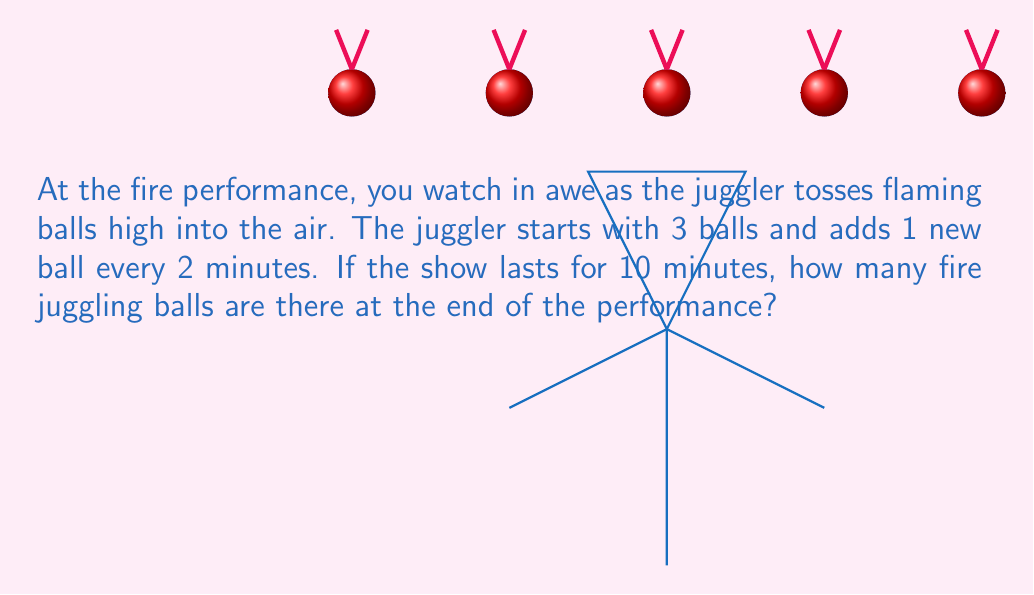Provide a solution to this math problem. Let's break this problem down step-by-step:

1) First, we need to determine how many times the juggler adds a new ball during the 10-minute performance.
   - The juggler adds 1 ball every 2 minutes.
   - So, we can calculate this by dividing the total performance time by the interval between adding balls:
     $$ \text{Number of additions} = \frac{\text{Total time}}{\text{Time between additions}} = \frac{10 \text{ minutes}}{2 \text{ minutes}} = 5 $$

2) Now we know the juggler adds a new ball 5 times during the performance.

3) The juggler starts with 3 balls, so we need to add this to the number of balls added:
   $$ \text{Total balls} = \text{Starting balls} + \text{Balls added} $$
   $$ \text{Total balls} = 3 + 5 = 8 $$

Therefore, at the end of the 10-minute performance, the juggler is using 8 fire juggling balls.
Answer: 8 balls 